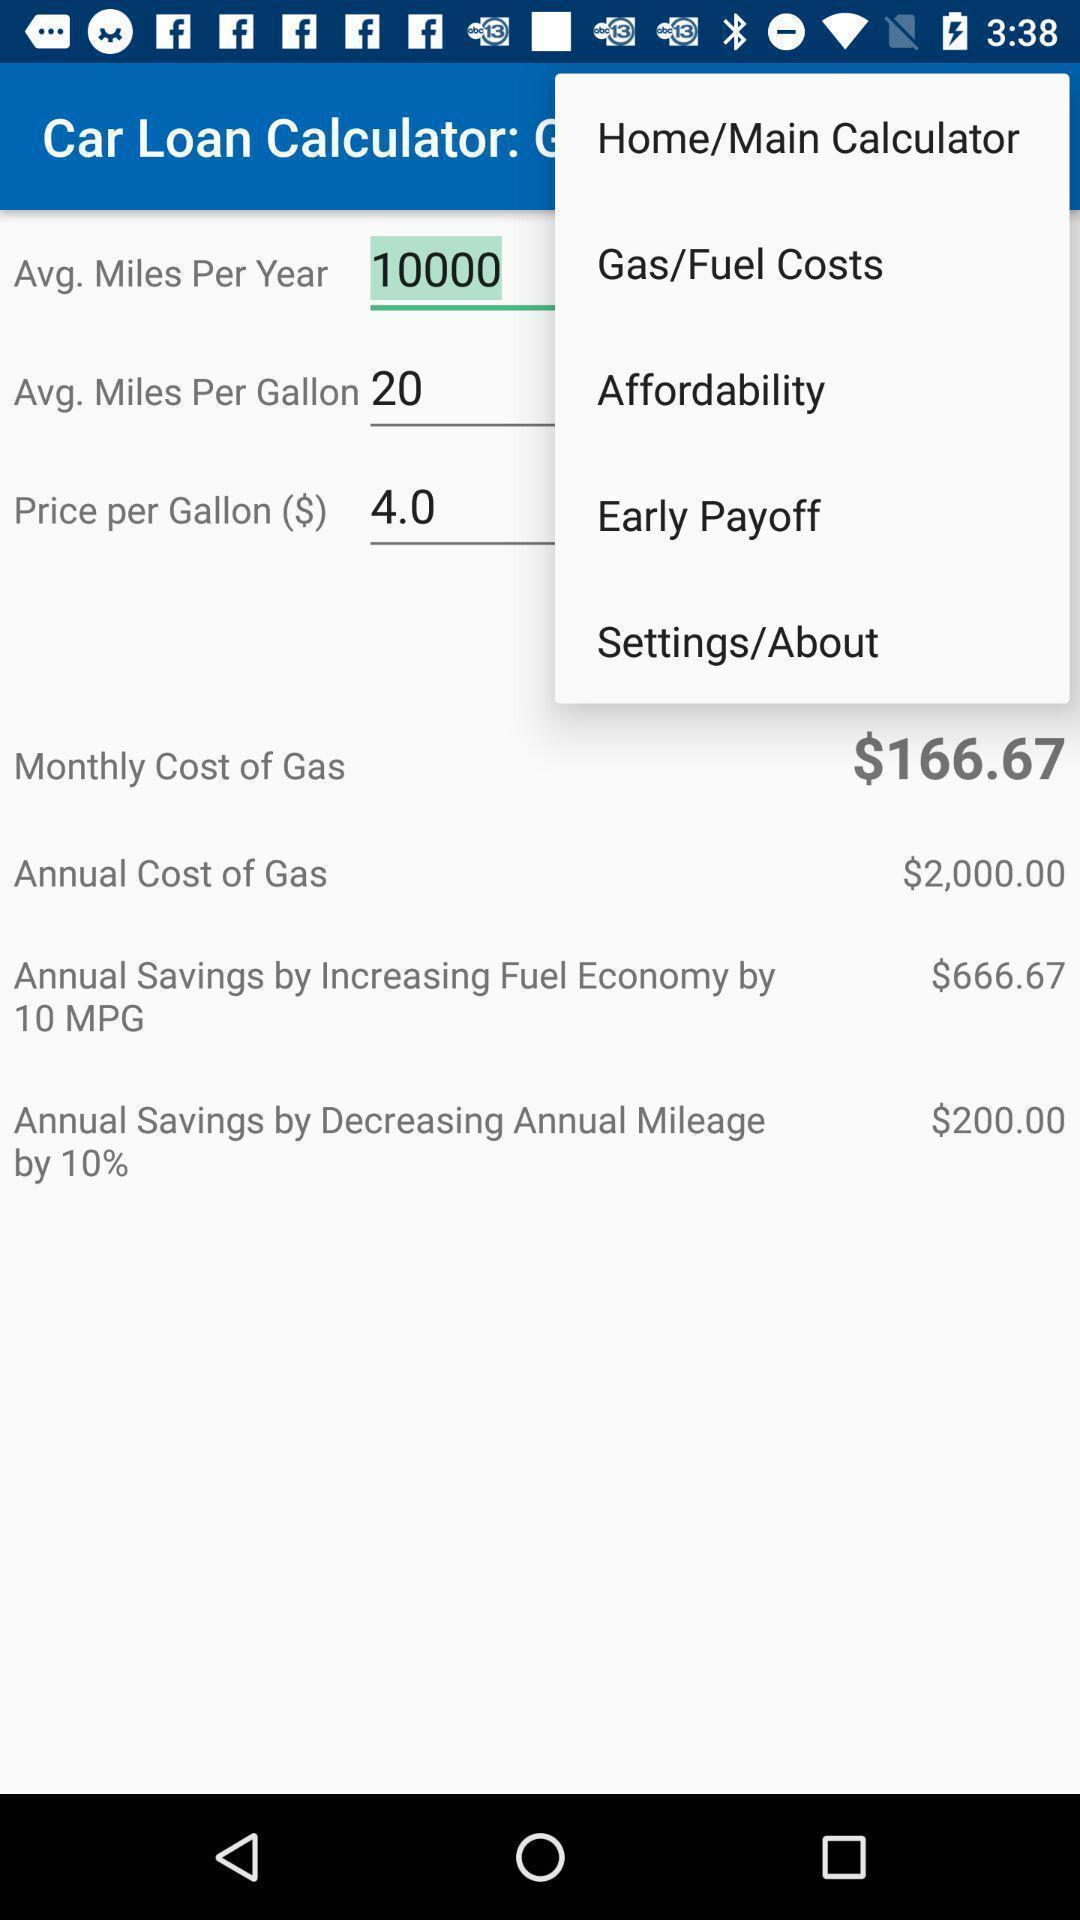Describe this image in words. Screen showing menu of options of a loan calculator. 